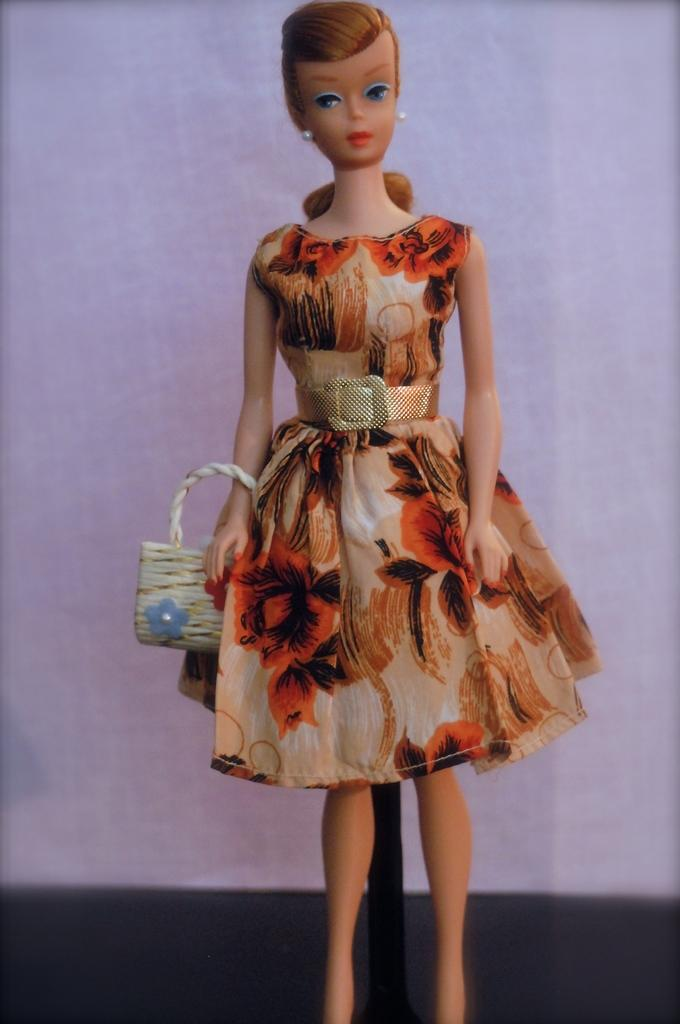What is the main subject of the image? There is a Barbie doll in the image. What is the Barbie doll doing in the image? The Barbie doll is standing in the image. What is the Barbie doll holding in the image? The Barbie doll is holding a handbag in the image. What can be seen in the background of the image? There is a light blue wall in the background of the image. What type of thunder can be heard in the image? There is no thunder present in the image, as it is a still photograph of a Barbie doll. 